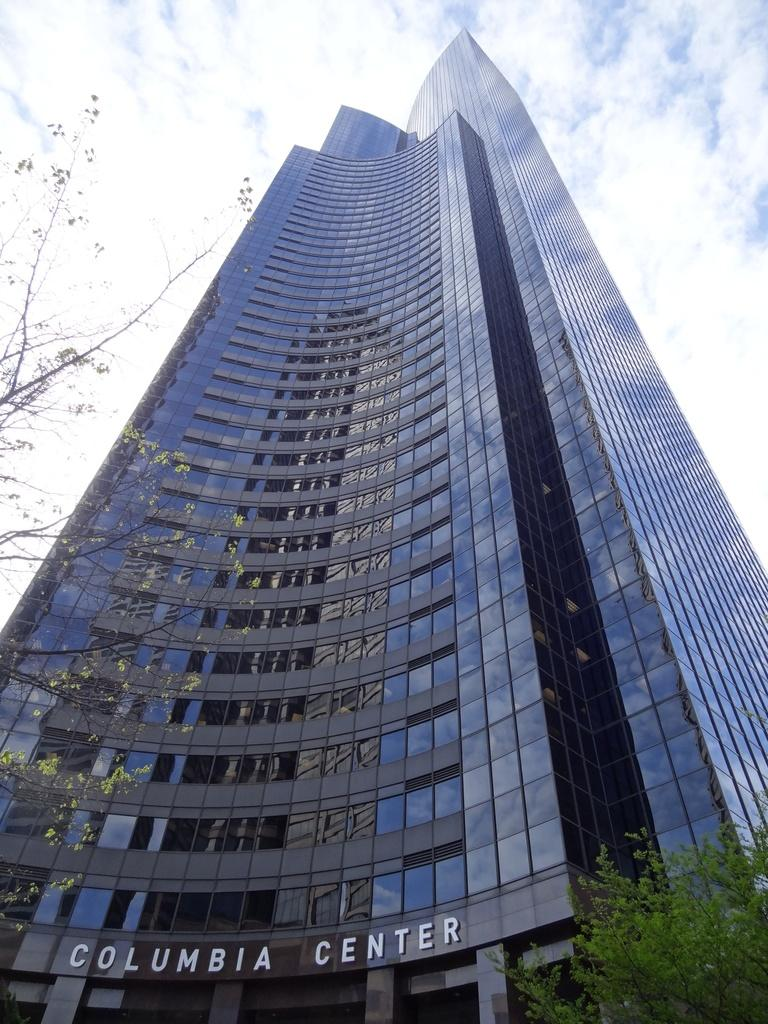What can be seen on the right side of the image? There is a tree on the right side of the image. What is visible in the background of the image? There is a building in the background of the image. What type of windows does the building have? The building has glass windows. What is displayed on the wall of the building? There is a hoarding on the wall of the building. What is visible in the sky in the image? There are clouds in the sky. Are there any giants visible in the image? There are no giants present in the image. What type of pan is being used to cook food in the image? There is no pan or cooking activity visible in the image. 